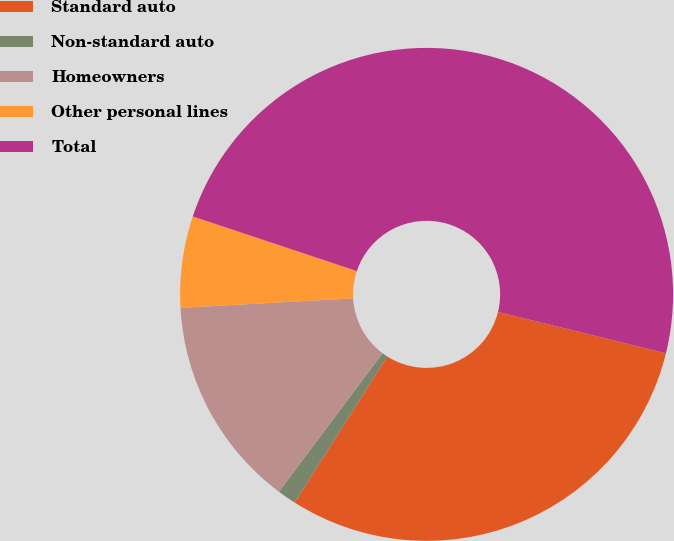Convert chart. <chart><loc_0><loc_0><loc_500><loc_500><pie_chart><fcel>Standard auto<fcel>Non-standard auto<fcel>Homeowners<fcel>Other personal lines<fcel>Total<nl><fcel>30.15%<fcel>1.24%<fcel>13.9%<fcel>5.99%<fcel>48.72%<nl></chart> 